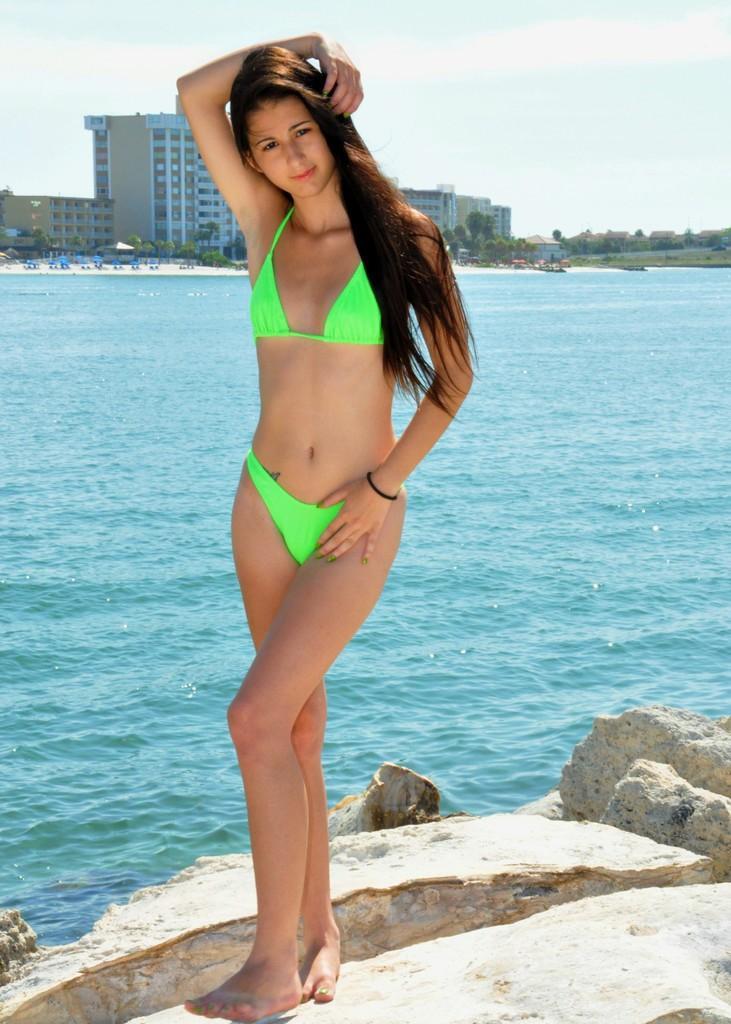Please provide a concise description of this image. In this picture there is a woman standing and we can see rocks and water. In the background of the image we can see buildings, trees and sky. 